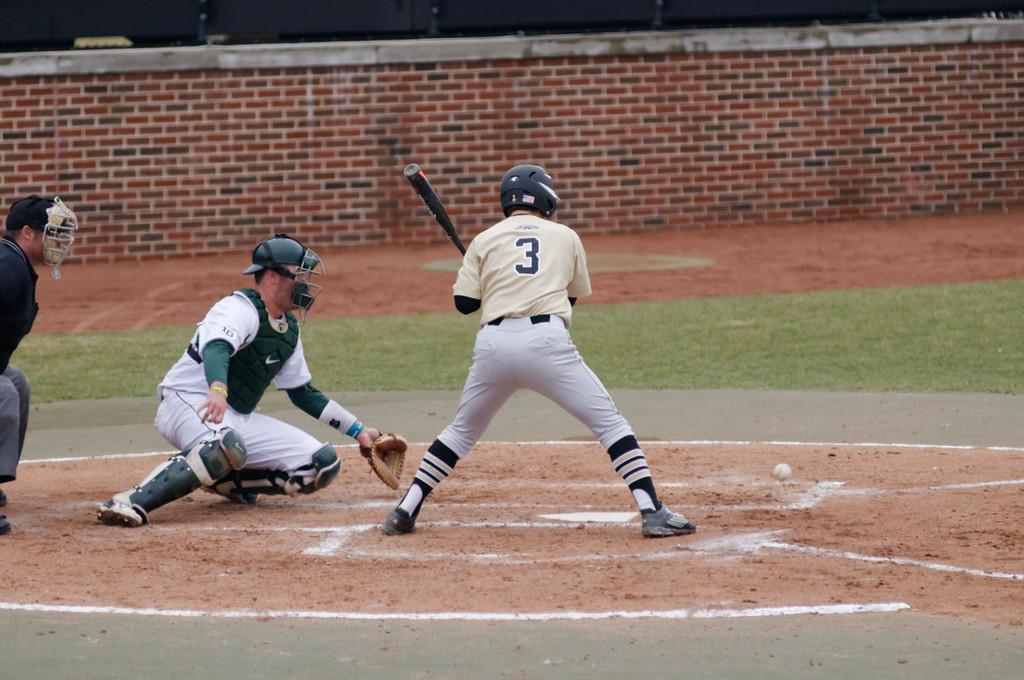<image>
Describe the image concisely. Baseball player number 3 is up to bat while the catcher is waiting for the ball. 